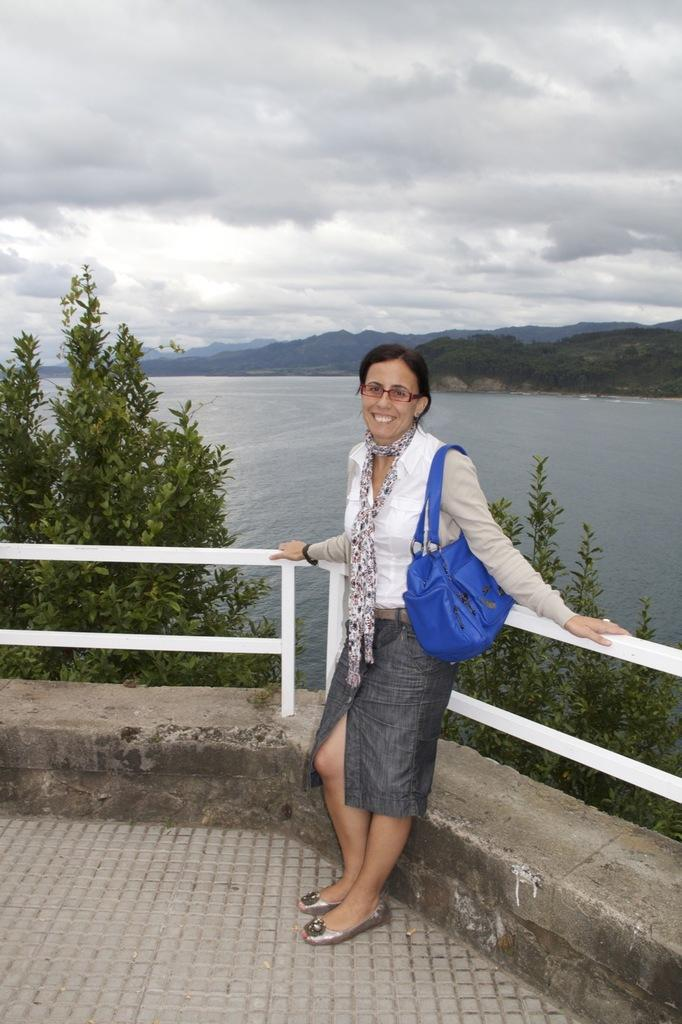Who is present in the image? There is a person in the image. What is the person doing in the image? The person is smiling in the image. What is the person holding in the image? The person is holding a bag in the image. What can be seen in the background of the image? There is a tree, water, a mountain, and the sky visible in the background of the image. What type of pancake is the person offering to the mountain in the image? There is no pancake present in the image, nor is the person offering anything to the mountain. 